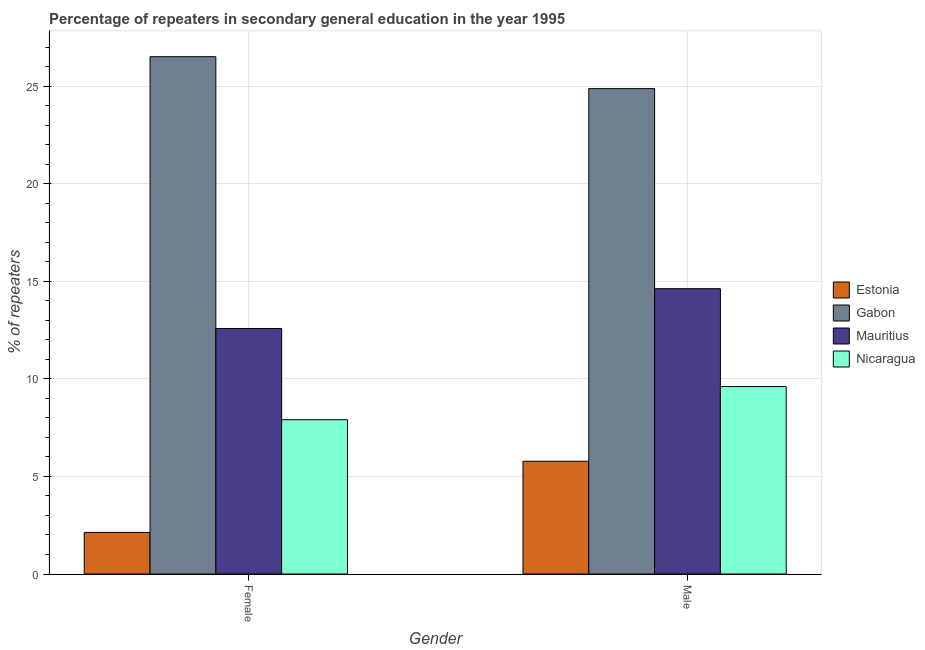Are the number of bars per tick equal to the number of legend labels?
Make the answer very short. Yes. How many bars are there on the 2nd tick from the left?
Offer a terse response. 4. How many bars are there on the 1st tick from the right?
Offer a terse response. 4. What is the percentage of male repeaters in Gabon?
Ensure brevity in your answer.  24.88. Across all countries, what is the maximum percentage of male repeaters?
Give a very brief answer. 24.88. Across all countries, what is the minimum percentage of female repeaters?
Provide a short and direct response. 2.13. In which country was the percentage of male repeaters maximum?
Your response must be concise. Gabon. In which country was the percentage of male repeaters minimum?
Offer a terse response. Estonia. What is the total percentage of male repeaters in the graph?
Your answer should be very brief. 54.89. What is the difference between the percentage of female repeaters in Mauritius and that in Estonia?
Offer a terse response. 10.45. What is the difference between the percentage of female repeaters in Gabon and the percentage of male repeaters in Estonia?
Make the answer very short. 20.74. What is the average percentage of female repeaters per country?
Offer a terse response. 12.28. What is the difference between the percentage of female repeaters and percentage of male repeaters in Estonia?
Your answer should be compact. -3.65. What is the ratio of the percentage of male repeaters in Estonia to that in Gabon?
Ensure brevity in your answer.  0.23. What does the 3rd bar from the left in Male represents?
Keep it short and to the point. Mauritius. What does the 1st bar from the right in Female represents?
Offer a very short reply. Nicaragua. How many bars are there?
Ensure brevity in your answer.  8. How many countries are there in the graph?
Offer a very short reply. 4. What is the difference between two consecutive major ticks on the Y-axis?
Keep it short and to the point. 5. Does the graph contain any zero values?
Offer a very short reply. No. Does the graph contain grids?
Offer a terse response. Yes. Where does the legend appear in the graph?
Your response must be concise. Center right. How many legend labels are there?
Your answer should be compact. 4. What is the title of the graph?
Ensure brevity in your answer.  Percentage of repeaters in secondary general education in the year 1995. What is the label or title of the Y-axis?
Provide a succinct answer. % of repeaters. What is the % of repeaters of Estonia in Female?
Provide a succinct answer. 2.13. What is the % of repeaters of Gabon in Female?
Provide a short and direct response. 26.52. What is the % of repeaters in Mauritius in Female?
Provide a succinct answer. 12.58. What is the % of repeaters in Nicaragua in Female?
Provide a succinct answer. 7.91. What is the % of repeaters in Estonia in Male?
Your response must be concise. 5.78. What is the % of repeaters of Gabon in Male?
Ensure brevity in your answer.  24.88. What is the % of repeaters of Mauritius in Male?
Your answer should be very brief. 14.62. What is the % of repeaters in Nicaragua in Male?
Provide a succinct answer. 9.61. Across all Gender, what is the maximum % of repeaters of Estonia?
Your response must be concise. 5.78. Across all Gender, what is the maximum % of repeaters in Gabon?
Provide a succinct answer. 26.52. Across all Gender, what is the maximum % of repeaters of Mauritius?
Ensure brevity in your answer.  14.62. Across all Gender, what is the maximum % of repeaters of Nicaragua?
Provide a short and direct response. 9.61. Across all Gender, what is the minimum % of repeaters of Estonia?
Make the answer very short. 2.13. Across all Gender, what is the minimum % of repeaters of Gabon?
Your answer should be very brief. 24.88. Across all Gender, what is the minimum % of repeaters of Mauritius?
Your answer should be compact. 12.58. Across all Gender, what is the minimum % of repeaters in Nicaragua?
Offer a very short reply. 7.91. What is the total % of repeaters in Estonia in the graph?
Provide a short and direct response. 7.91. What is the total % of repeaters in Gabon in the graph?
Keep it short and to the point. 51.39. What is the total % of repeaters in Mauritius in the graph?
Your answer should be compact. 27.21. What is the total % of repeaters in Nicaragua in the graph?
Offer a very short reply. 17.51. What is the difference between the % of repeaters of Estonia in Female and that in Male?
Offer a very short reply. -3.65. What is the difference between the % of repeaters in Gabon in Female and that in Male?
Ensure brevity in your answer.  1.64. What is the difference between the % of repeaters of Mauritius in Female and that in Male?
Your response must be concise. -2.04. What is the difference between the % of repeaters in Nicaragua in Female and that in Male?
Your answer should be compact. -1.7. What is the difference between the % of repeaters in Estonia in Female and the % of repeaters in Gabon in Male?
Provide a succinct answer. -22.75. What is the difference between the % of repeaters in Estonia in Female and the % of repeaters in Mauritius in Male?
Keep it short and to the point. -12.49. What is the difference between the % of repeaters of Estonia in Female and the % of repeaters of Nicaragua in Male?
Ensure brevity in your answer.  -7.48. What is the difference between the % of repeaters of Gabon in Female and the % of repeaters of Mauritius in Male?
Give a very brief answer. 11.89. What is the difference between the % of repeaters of Gabon in Female and the % of repeaters of Nicaragua in Male?
Keep it short and to the point. 16.91. What is the difference between the % of repeaters of Mauritius in Female and the % of repeaters of Nicaragua in Male?
Your answer should be very brief. 2.98. What is the average % of repeaters in Estonia per Gender?
Offer a very short reply. 3.96. What is the average % of repeaters in Gabon per Gender?
Provide a succinct answer. 25.7. What is the average % of repeaters of Mauritius per Gender?
Your answer should be very brief. 13.6. What is the average % of repeaters of Nicaragua per Gender?
Offer a terse response. 8.76. What is the difference between the % of repeaters in Estonia and % of repeaters in Gabon in Female?
Your answer should be compact. -24.38. What is the difference between the % of repeaters in Estonia and % of repeaters in Mauritius in Female?
Your response must be concise. -10.45. What is the difference between the % of repeaters of Estonia and % of repeaters of Nicaragua in Female?
Give a very brief answer. -5.78. What is the difference between the % of repeaters in Gabon and % of repeaters in Mauritius in Female?
Make the answer very short. 13.93. What is the difference between the % of repeaters in Gabon and % of repeaters in Nicaragua in Female?
Your answer should be very brief. 18.61. What is the difference between the % of repeaters in Mauritius and % of repeaters in Nicaragua in Female?
Your answer should be very brief. 4.68. What is the difference between the % of repeaters in Estonia and % of repeaters in Gabon in Male?
Ensure brevity in your answer.  -19.1. What is the difference between the % of repeaters in Estonia and % of repeaters in Mauritius in Male?
Provide a short and direct response. -8.84. What is the difference between the % of repeaters in Estonia and % of repeaters in Nicaragua in Male?
Your answer should be very brief. -3.83. What is the difference between the % of repeaters of Gabon and % of repeaters of Mauritius in Male?
Provide a succinct answer. 10.25. What is the difference between the % of repeaters in Gabon and % of repeaters in Nicaragua in Male?
Keep it short and to the point. 15.27. What is the difference between the % of repeaters in Mauritius and % of repeaters in Nicaragua in Male?
Your answer should be compact. 5.02. What is the ratio of the % of repeaters in Estonia in Female to that in Male?
Keep it short and to the point. 0.37. What is the ratio of the % of repeaters of Gabon in Female to that in Male?
Keep it short and to the point. 1.07. What is the ratio of the % of repeaters of Mauritius in Female to that in Male?
Offer a very short reply. 0.86. What is the ratio of the % of repeaters in Nicaragua in Female to that in Male?
Keep it short and to the point. 0.82. What is the difference between the highest and the second highest % of repeaters in Estonia?
Make the answer very short. 3.65. What is the difference between the highest and the second highest % of repeaters in Gabon?
Give a very brief answer. 1.64. What is the difference between the highest and the second highest % of repeaters of Mauritius?
Keep it short and to the point. 2.04. What is the difference between the highest and the second highest % of repeaters in Nicaragua?
Your answer should be compact. 1.7. What is the difference between the highest and the lowest % of repeaters in Estonia?
Provide a short and direct response. 3.65. What is the difference between the highest and the lowest % of repeaters of Gabon?
Offer a very short reply. 1.64. What is the difference between the highest and the lowest % of repeaters in Mauritius?
Your response must be concise. 2.04. What is the difference between the highest and the lowest % of repeaters of Nicaragua?
Offer a terse response. 1.7. 